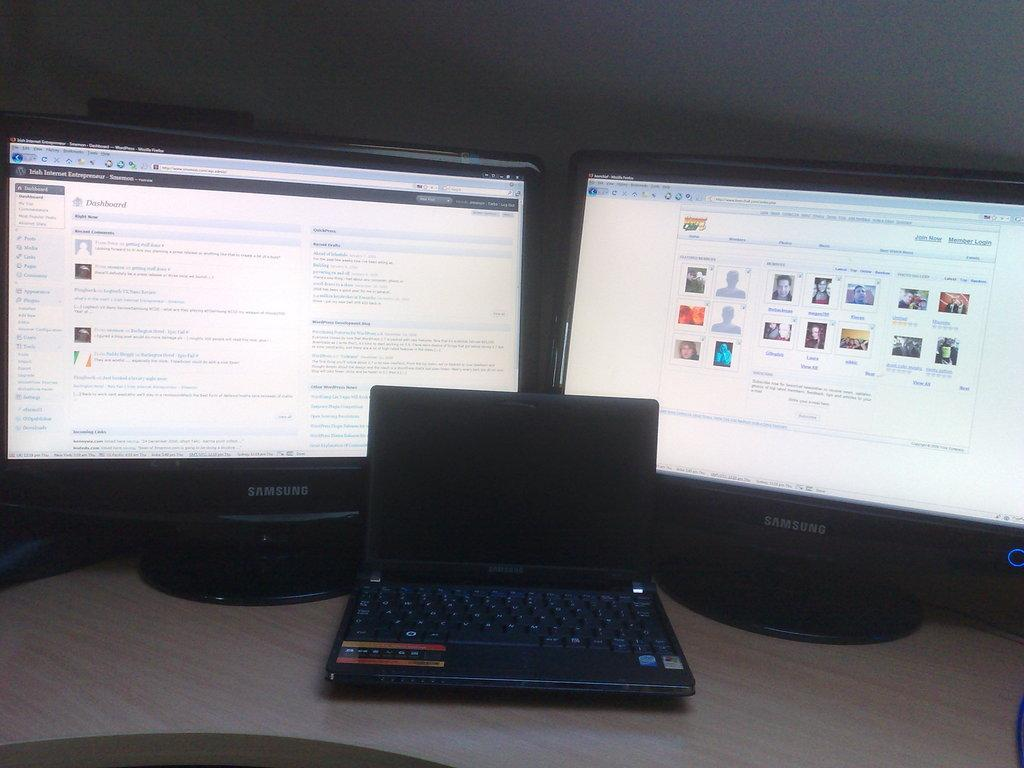<image>
Provide a brief description of the given image. Multiple computer screens, one showing the Dashboard of a software. 